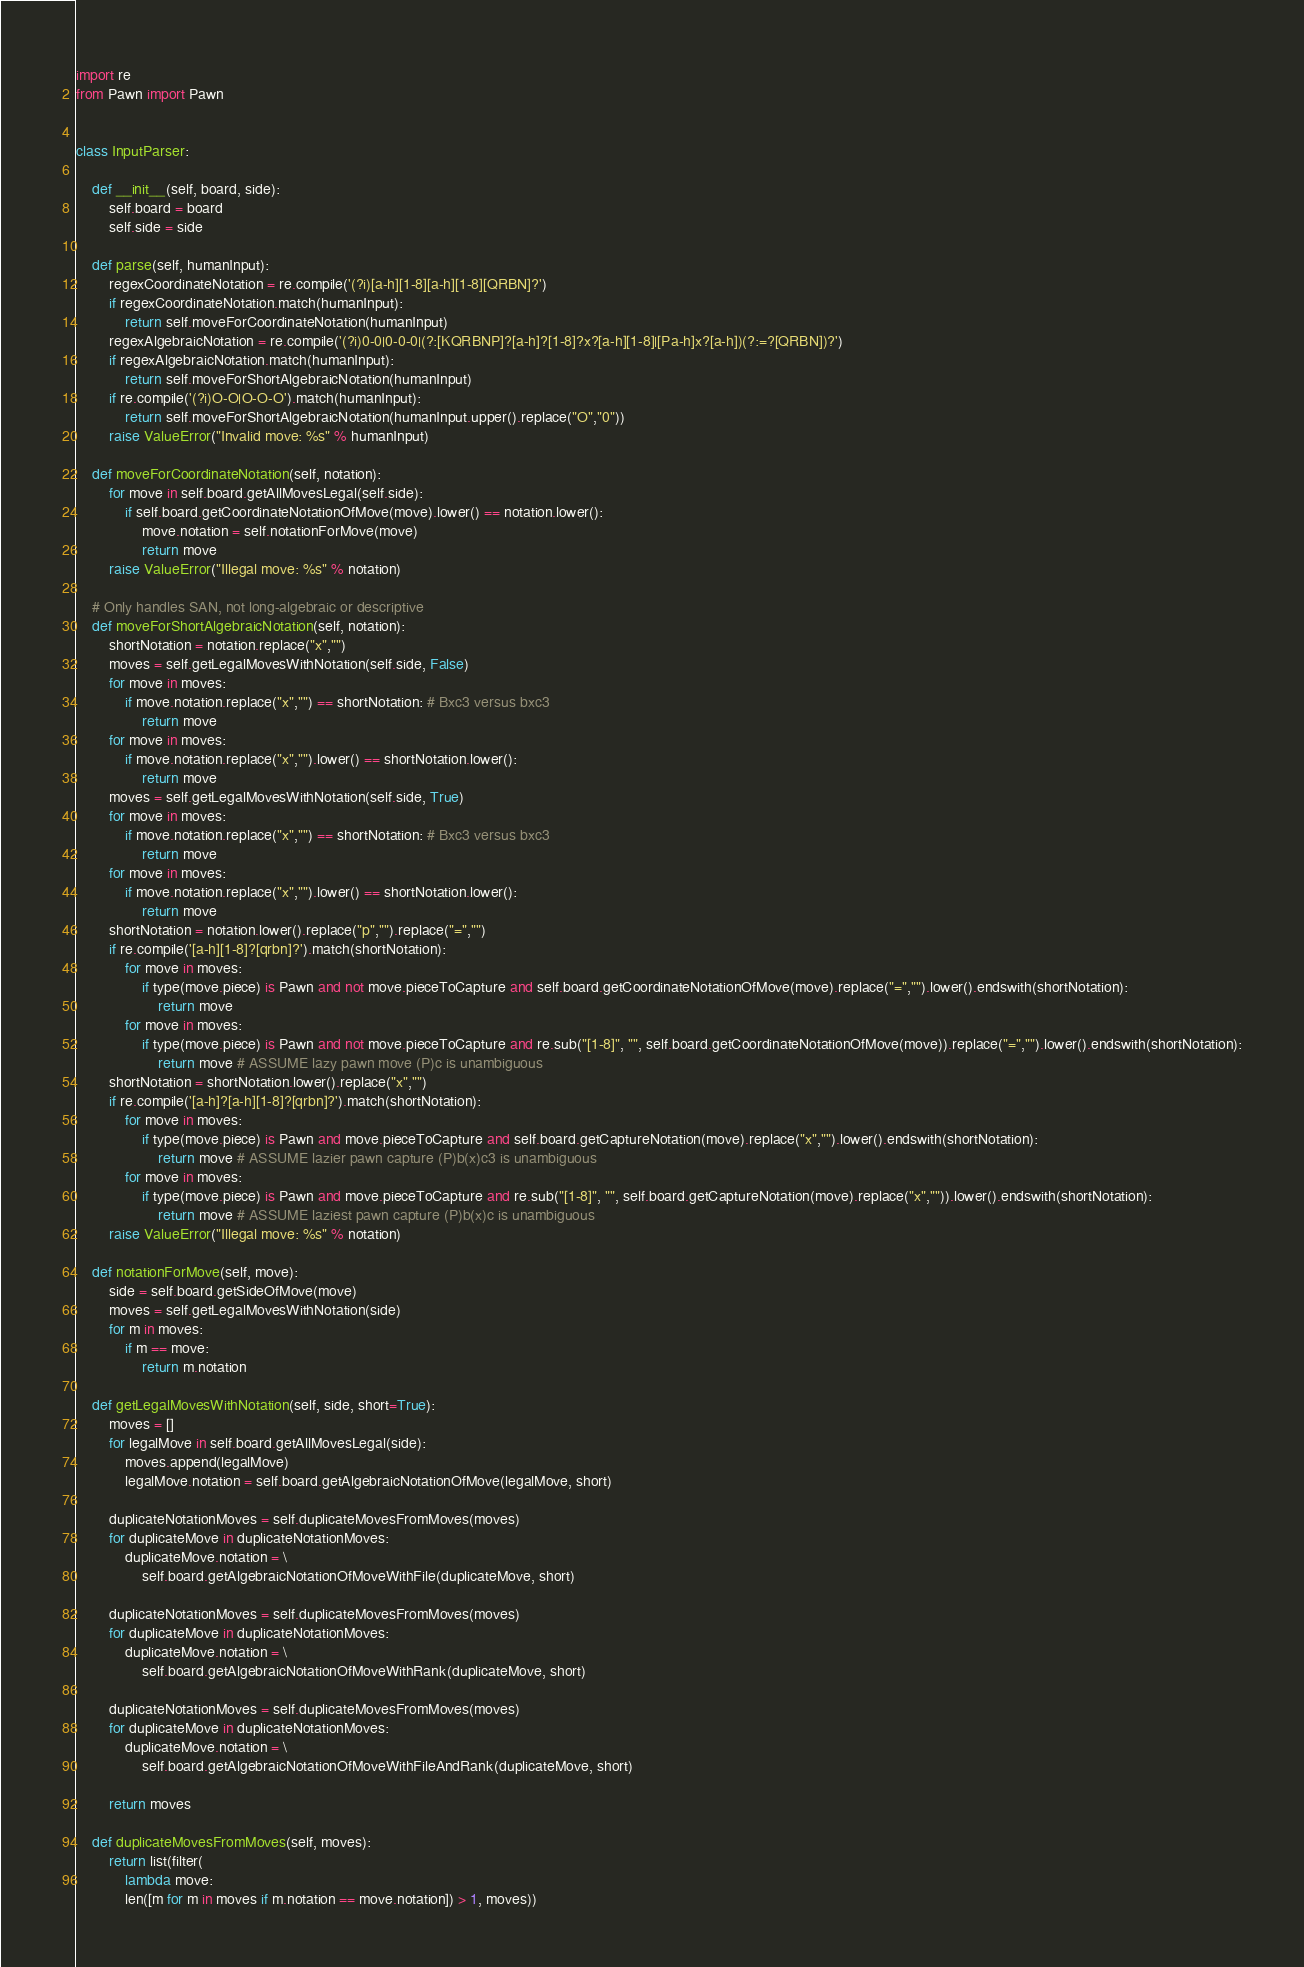<code> <loc_0><loc_0><loc_500><loc_500><_Python_>import re
from Pawn import Pawn


class InputParser:

    def __init__(self, board, side):
        self.board = board
        self.side = side

    def parse(self, humanInput):
        regexCoordinateNotation = re.compile('(?i)[a-h][1-8][a-h][1-8][QRBN]?')
        if regexCoordinateNotation.match(humanInput):
            return self.moveForCoordinateNotation(humanInput)
        regexAlgebraicNotation = re.compile('(?i)0-0|0-0-0|(?:[KQRBNP]?[a-h]?[1-8]?x?[a-h][1-8]|[Pa-h]x?[a-h])(?:=?[QRBN])?')
        if regexAlgebraicNotation.match(humanInput):
            return self.moveForShortAlgebraicNotation(humanInput)
        if re.compile('(?i)O-O|O-O-O').match(humanInput):
            return self.moveForShortAlgebraicNotation(humanInput.upper().replace("O","0"))
        raise ValueError("Invalid move: %s" % humanInput)

    def moveForCoordinateNotation(self, notation):
        for move in self.board.getAllMovesLegal(self.side):
            if self.board.getCoordinateNotationOfMove(move).lower() == notation.lower():
                move.notation = self.notationForMove(move)
                return move
        raise ValueError("Illegal move: %s" % notation)

    # Only handles SAN, not long-algebraic or descriptive
    def moveForShortAlgebraicNotation(self, notation):
        shortNotation = notation.replace("x","")
        moves = self.getLegalMovesWithNotation(self.side, False)
        for move in moves:
            if move.notation.replace("x","") == shortNotation: # Bxc3 versus bxc3
                return move
        for move in moves:
            if move.notation.replace("x","").lower() == shortNotation.lower():
                return move
        moves = self.getLegalMovesWithNotation(self.side, True)
        for move in moves:
            if move.notation.replace("x","") == shortNotation: # Bxc3 versus bxc3
                return move
        for move in moves:
            if move.notation.replace("x","").lower() == shortNotation.lower():
                return move
        shortNotation = notation.lower().replace("p","").replace("=","")
        if re.compile('[a-h][1-8]?[qrbn]?').match(shortNotation):
            for move in moves:
                if type(move.piece) is Pawn and not move.pieceToCapture and self.board.getCoordinateNotationOfMove(move).replace("=","").lower().endswith(shortNotation):
                    return move
            for move in moves:
                if type(move.piece) is Pawn and not move.pieceToCapture and re.sub("[1-8]", "", self.board.getCoordinateNotationOfMove(move)).replace("=","").lower().endswith(shortNotation):
                    return move # ASSUME lazy pawn move (P)c is unambiguous
        shortNotation = shortNotation.lower().replace("x","")
        if re.compile('[a-h]?[a-h][1-8]?[qrbn]?').match(shortNotation):
            for move in moves:
                if type(move.piece) is Pawn and move.pieceToCapture and self.board.getCaptureNotation(move).replace("x","").lower().endswith(shortNotation):
                    return move # ASSUME lazier pawn capture (P)b(x)c3 is unambiguous
            for move in moves:
                if type(move.piece) is Pawn and move.pieceToCapture and re.sub("[1-8]", "", self.board.getCaptureNotation(move).replace("x","")).lower().endswith(shortNotation):
                    return move # ASSUME laziest pawn capture (P)b(x)c is unambiguous
        raise ValueError("Illegal move: %s" % notation)

    def notationForMove(self, move):
        side = self.board.getSideOfMove(move)
        moves = self.getLegalMovesWithNotation(side)
        for m in moves:
            if m == move:
                return m.notation

    def getLegalMovesWithNotation(self, side, short=True):
        moves = []
        for legalMove in self.board.getAllMovesLegal(side):
            moves.append(legalMove)
            legalMove.notation = self.board.getAlgebraicNotationOfMove(legalMove, short)

        duplicateNotationMoves = self.duplicateMovesFromMoves(moves)
        for duplicateMove in duplicateNotationMoves:
            duplicateMove.notation = \
                self.board.getAlgebraicNotationOfMoveWithFile(duplicateMove, short)

        duplicateNotationMoves = self.duplicateMovesFromMoves(moves)
        for duplicateMove in duplicateNotationMoves:
            duplicateMove.notation = \
                self.board.getAlgebraicNotationOfMoveWithRank(duplicateMove, short)

        duplicateNotationMoves = self.duplicateMovesFromMoves(moves)
        for duplicateMove in duplicateNotationMoves:
            duplicateMove.notation = \
                self.board.getAlgebraicNotationOfMoveWithFileAndRank(duplicateMove, short)

        return moves

    def duplicateMovesFromMoves(self, moves):
        return list(filter(
            lambda move:
            len([m for m in moves if m.notation == move.notation]) > 1, moves))
</code> 